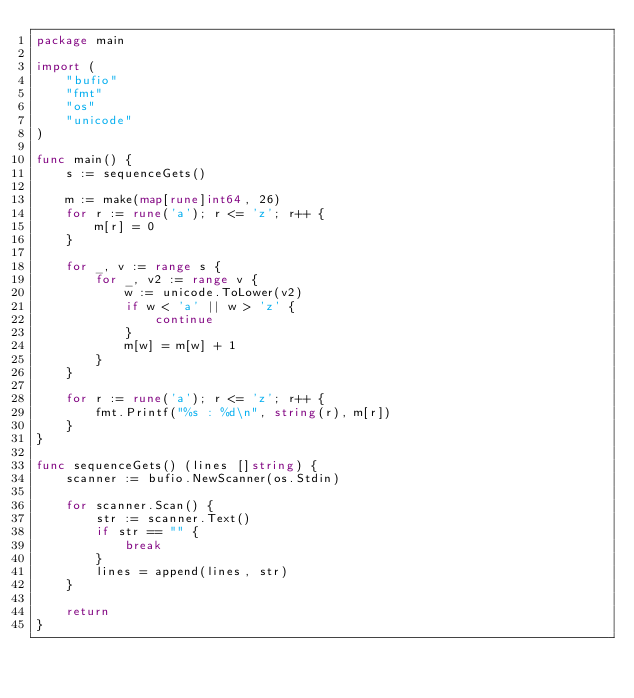<code> <loc_0><loc_0><loc_500><loc_500><_Go_>package main

import (
	"bufio"
	"fmt"
	"os"
	"unicode"
)

func main() {
	s := sequenceGets()

	m := make(map[rune]int64, 26)
	for r := rune('a'); r <= 'z'; r++ {
		m[r] = 0
	}

	for _, v := range s {
		for _, v2 := range v {
			w := unicode.ToLower(v2)
			if w < 'a' || w > 'z' {
				continue
			}
			m[w] = m[w] + 1
		}
	}

	for r := rune('a'); r <= 'z'; r++ {
		fmt.Printf("%s : %d\n", string(r), m[r])
	}
}

func sequenceGets() (lines []string) {
	scanner := bufio.NewScanner(os.Stdin)

	for scanner.Scan() {
		str := scanner.Text()
		if str == "" {
			break
		}
		lines = append(lines, str)
	}

	return
}

</code> 